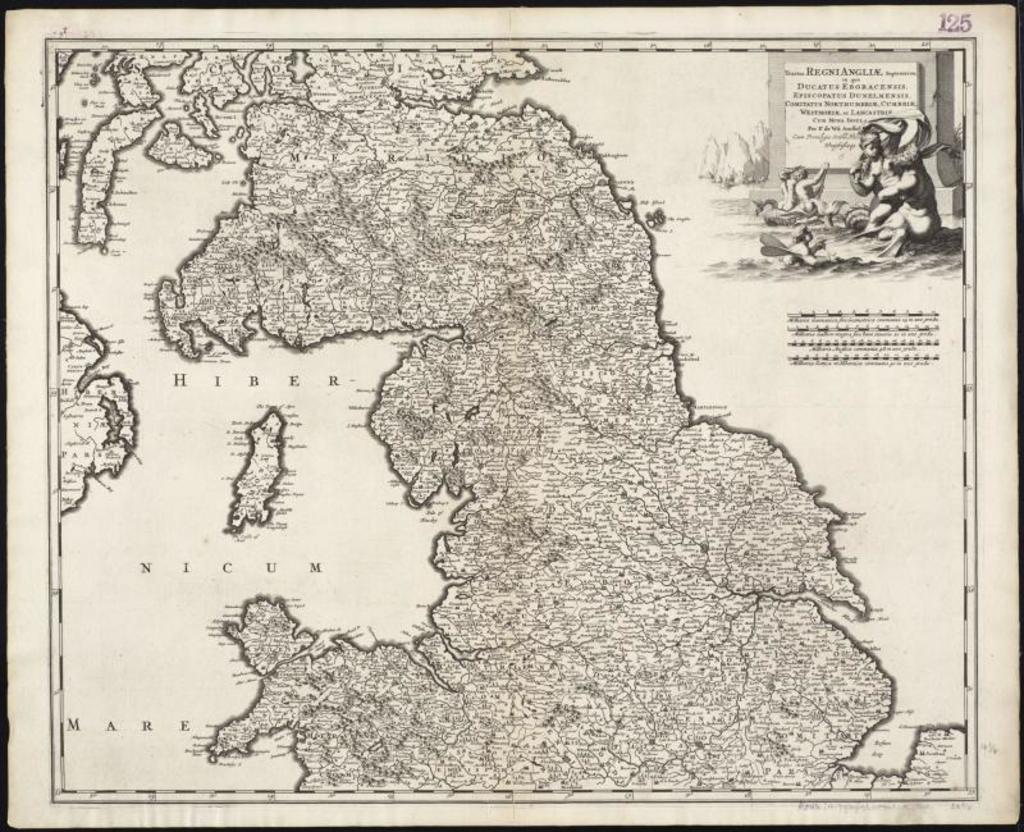How would you summarize this image in a sentence or two? In this image we can see a poster. On this poster we can see a map, pictures, and something is written on it. 